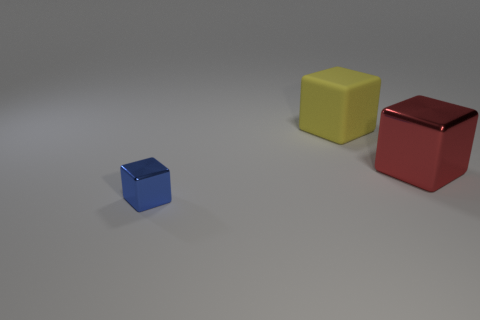Is there any other thing that is the same material as the large yellow cube?
Ensure brevity in your answer.  No. There is another object that is the same size as the red shiny thing; what is its color?
Keep it short and to the point. Yellow. How many cyan objects are either large matte cubes or tiny things?
Your answer should be very brief. 0. Are there more red cubes than objects?
Ensure brevity in your answer.  No. Is the size of the cube that is in front of the red block the same as the object behind the red cube?
Ensure brevity in your answer.  No. The shiny block right of the object that is left of the block that is behind the big red block is what color?
Offer a very short reply. Red. Is there another large blue thing of the same shape as the big rubber object?
Your answer should be compact. No. Is the number of yellow matte objects that are right of the blue shiny thing greater than the number of tiny brown rubber things?
Keep it short and to the point. Yes. How many matte objects are either tiny blue cubes or small green balls?
Your response must be concise. 0. What size is the thing that is to the left of the red cube and in front of the yellow cube?
Your response must be concise. Small. 